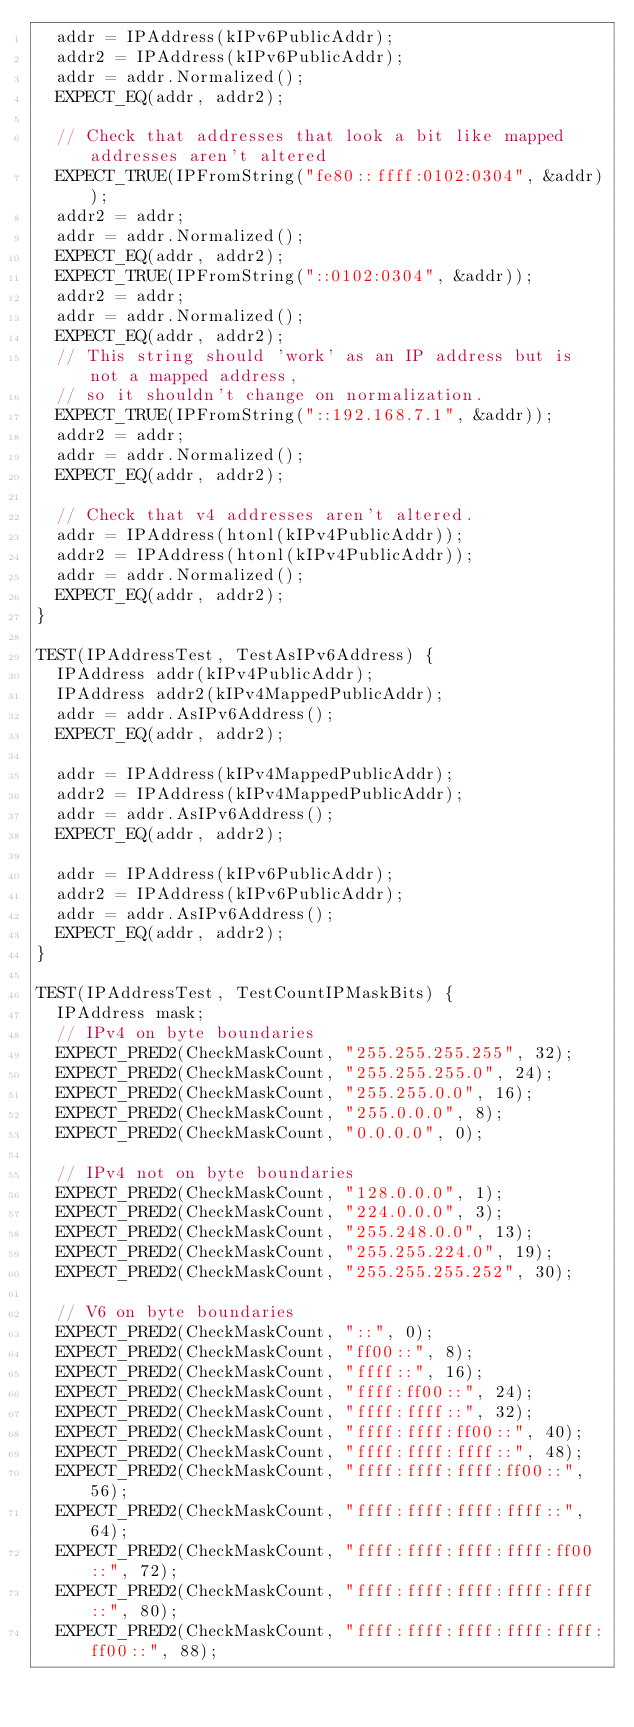<code> <loc_0><loc_0><loc_500><loc_500><_C++_>  addr = IPAddress(kIPv6PublicAddr);
  addr2 = IPAddress(kIPv6PublicAddr);
  addr = addr.Normalized();
  EXPECT_EQ(addr, addr2);

  // Check that addresses that look a bit like mapped addresses aren't altered
  EXPECT_TRUE(IPFromString("fe80::ffff:0102:0304", &addr));
  addr2 = addr;
  addr = addr.Normalized();
  EXPECT_EQ(addr, addr2);
  EXPECT_TRUE(IPFromString("::0102:0304", &addr));
  addr2 = addr;
  addr = addr.Normalized();
  EXPECT_EQ(addr, addr2);
  // This string should 'work' as an IP address but is not a mapped address,
  // so it shouldn't change on normalization.
  EXPECT_TRUE(IPFromString("::192.168.7.1", &addr));
  addr2 = addr;
  addr = addr.Normalized();
  EXPECT_EQ(addr, addr2);

  // Check that v4 addresses aren't altered.
  addr = IPAddress(htonl(kIPv4PublicAddr));
  addr2 = IPAddress(htonl(kIPv4PublicAddr));
  addr = addr.Normalized();
  EXPECT_EQ(addr, addr2);
}

TEST(IPAddressTest, TestAsIPv6Address) {
  IPAddress addr(kIPv4PublicAddr);
  IPAddress addr2(kIPv4MappedPublicAddr);
  addr = addr.AsIPv6Address();
  EXPECT_EQ(addr, addr2);

  addr = IPAddress(kIPv4MappedPublicAddr);
  addr2 = IPAddress(kIPv4MappedPublicAddr);
  addr = addr.AsIPv6Address();
  EXPECT_EQ(addr, addr2);

  addr = IPAddress(kIPv6PublicAddr);
  addr2 = IPAddress(kIPv6PublicAddr);
  addr = addr.AsIPv6Address();
  EXPECT_EQ(addr, addr2);
}

TEST(IPAddressTest, TestCountIPMaskBits) {
  IPAddress mask;
  // IPv4 on byte boundaries
  EXPECT_PRED2(CheckMaskCount, "255.255.255.255", 32);
  EXPECT_PRED2(CheckMaskCount, "255.255.255.0", 24);
  EXPECT_PRED2(CheckMaskCount, "255.255.0.0", 16);
  EXPECT_PRED2(CheckMaskCount, "255.0.0.0", 8);
  EXPECT_PRED2(CheckMaskCount, "0.0.0.0", 0);

  // IPv4 not on byte boundaries
  EXPECT_PRED2(CheckMaskCount, "128.0.0.0", 1);
  EXPECT_PRED2(CheckMaskCount, "224.0.0.0", 3);
  EXPECT_PRED2(CheckMaskCount, "255.248.0.0", 13);
  EXPECT_PRED2(CheckMaskCount, "255.255.224.0", 19);
  EXPECT_PRED2(CheckMaskCount, "255.255.255.252", 30);

  // V6 on byte boundaries
  EXPECT_PRED2(CheckMaskCount, "::", 0);
  EXPECT_PRED2(CheckMaskCount, "ff00::", 8);
  EXPECT_PRED2(CheckMaskCount, "ffff::", 16);
  EXPECT_PRED2(CheckMaskCount, "ffff:ff00::", 24);
  EXPECT_PRED2(CheckMaskCount, "ffff:ffff::", 32);
  EXPECT_PRED2(CheckMaskCount, "ffff:ffff:ff00::", 40);
  EXPECT_PRED2(CheckMaskCount, "ffff:ffff:ffff::", 48);
  EXPECT_PRED2(CheckMaskCount, "ffff:ffff:ffff:ff00::", 56);
  EXPECT_PRED2(CheckMaskCount, "ffff:ffff:ffff:ffff::", 64);
  EXPECT_PRED2(CheckMaskCount, "ffff:ffff:ffff:ffff:ff00::", 72);
  EXPECT_PRED2(CheckMaskCount, "ffff:ffff:ffff:ffff:ffff::", 80);
  EXPECT_PRED2(CheckMaskCount, "ffff:ffff:ffff:ffff:ffff:ff00::", 88);</code> 